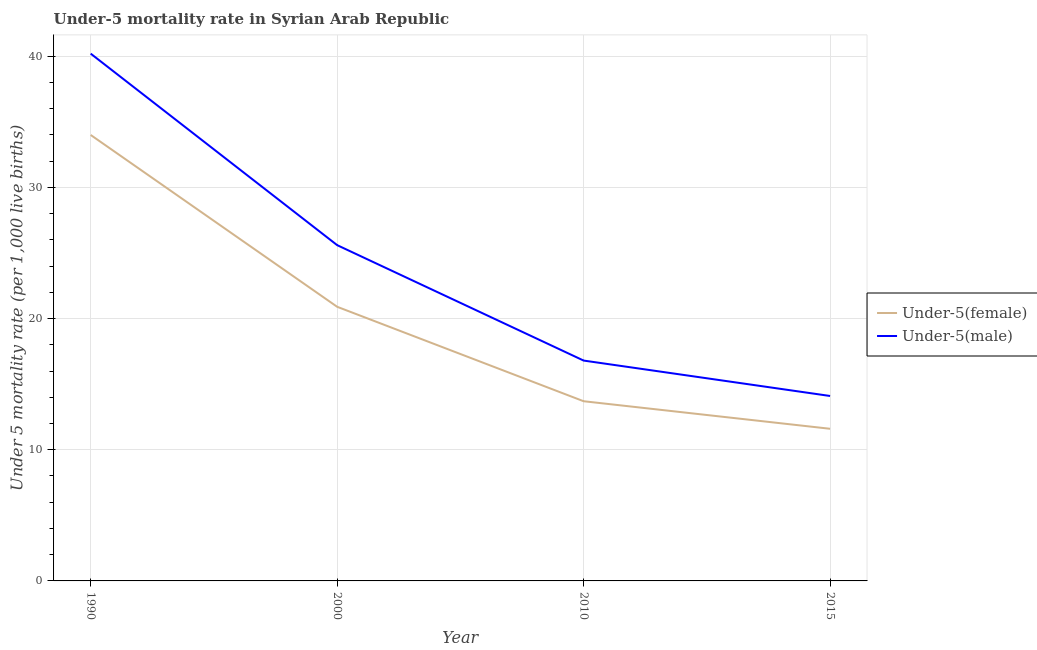Is the number of lines equal to the number of legend labels?
Provide a short and direct response. Yes. What is the under-5 female mortality rate in 2000?
Offer a terse response. 20.9. Across all years, what is the maximum under-5 male mortality rate?
Make the answer very short. 40.2. Across all years, what is the minimum under-5 female mortality rate?
Offer a very short reply. 11.6. In which year was the under-5 male mortality rate minimum?
Offer a very short reply. 2015. What is the total under-5 female mortality rate in the graph?
Your answer should be very brief. 80.2. What is the difference between the under-5 male mortality rate in 2000 and that in 2015?
Provide a succinct answer. 11.5. What is the difference between the under-5 male mortality rate in 2000 and the under-5 female mortality rate in 1990?
Give a very brief answer. -8.4. What is the average under-5 male mortality rate per year?
Provide a succinct answer. 24.18. In the year 2010, what is the difference between the under-5 male mortality rate and under-5 female mortality rate?
Keep it short and to the point. 3.1. In how many years, is the under-5 male mortality rate greater than 10?
Keep it short and to the point. 4. What is the ratio of the under-5 female mortality rate in 2010 to that in 2015?
Give a very brief answer. 1.18. Is the difference between the under-5 female mortality rate in 1990 and 2000 greater than the difference between the under-5 male mortality rate in 1990 and 2000?
Ensure brevity in your answer.  No. What is the difference between the highest and the second highest under-5 male mortality rate?
Give a very brief answer. 14.6. What is the difference between the highest and the lowest under-5 female mortality rate?
Offer a terse response. 22.4. In how many years, is the under-5 male mortality rate greater than the average under-5 male mortality rate taken over all years?
Your response must be concise. 2. Is the under-5 female mortality rate strictly greater than the under-5 male mortality rate over the years?
Your response must be concise. No. Does the graph contain any zero values?
Your answer should be compact. No. Does the graph contain grids?
Give a very brief answer. Yes. Where does the legend appear in the graph?
Offer a terse response. Center right. What is the title of the graph?
Your response must be concise. Under-5 mortality rate in Syrian Arab Republic. Does "Under-5(female)" appear as one of the legend labels in the graph?
Your response must be concise. Yes. What is the label or title of the X-axis?
Give a very brief answer. Year. What is the label or title of the Y-axis?
Offer a very short reply. Under 5 mortality rate (per 1,0 live births). What is the Under 5 mortality rate (per 1,000 live births) of Under-5(male) in 1990?
Make the answer very short. 40.2. What is the Under 5 mortality rate (per 1,000 live births) in Under-5(female) in 2000?
Offer a terse response. 20.9. What is the Under 5 mortality rate (per 1,000 live births) of Under-5(male) in 2000?
Give a very brief answer. 25.6. What is the Under 5 mortality rate (per 1,000 live births) in Under-5(female) in 2010?
Give a very brief answer. 13.7. What is the Under 5 mortality rate (per 1,000 live births) in Under-5(female) in 2015?
Give a very brief answer. 11.6. Across all years, what is the maximum Under 5 mortality rate (per 1,000 live births) of Under-5(female)?
Your response must be concise. 34. Across all years, what is the maximum Under 5 mortality rate (per 1,000 live births) of Under-5(male)?
Keep it short and to the point. 40.2. Across all years, what is the minimum Under 5 mortality rate (per 1,000 live births) of Under-5(male)?
Your answer should be very brief. 14.1. What is the total Under 5 mortality rate (per 1,000 live births) in Under-5(female) in the graph?
Provide a short and direct response. 80.2. What is the total Under 5 mortality rate (per 1,000 live births) in Under-5(male) in the graph?
Give a very brief answer. 96.7. What is the difference between the Under 5 mortality rate (per 1,000 live births) of Under-5(male) in 1990 and that in 2000?
Offer a very short reply. 14.6. What is the difference between the Under 5 mortality rate (per 1,000 live births) in Under-5(female) in 1990 and that in 2010?
Give a very brief answer. 20.3. What is the difference between the Under 5 mortality rate (per 1,000 live births) in Under-5(male) in 1990 and that in 2010?
Make the answer very short. 23.4. What is the difference between the Under 5 mortality rate (per 1,000 live births) in Under-5(female) in 1990 and that in 2015?
Offer a terse response. 22.4. What is the difference between the Under 5 mortality rate (per 1,000 live births) of Under-5(male) in 1990 and that in 2015?
Your answer should be compact. 26.1. What is the difference between the Under 5 mortality rate (per 1,000 live births) in Under-5(female) in 2000 and that in 2010?
Make the answer very short. 7.2. What is the difference between the Under 5 mortality rate (per 1,000 live births) of Under-5(male) in 2000 and that in 2010?
Your response must be concise. 8.8. What is the difference between the Under 5 mortality rate (per 1,000 live births) of Under-5(female) in 2000 and that in 2015?
Your response must be concise. 9.3. What is the difference between the Under 5 mortality rate (per 1,000 live births) of Under-5(male) in 2010 and that in 2015?
Your response must be concise. 2.7. What is the difference between the Under 5 mortality rate (per 1,000 live births) of Under-5(female) in 1990 and the Under 5 mortality rate (per 1,000 live births) of Under-5(male) in 2010?
Give a very brief answer. 17.2. What is the difference between the Under 5 mortality rate (per 1,000 live births) of Under-5(female) in 2000 and the Under 5 mortality rate (per 1,000 live births) of Under-5(male) in 2015?
Provide a short and direct response. 6.8. What is the difference between the Under 5 mortality rate (per 1,000 live births) in Under-5(female) in 2010 and the Under 5 mortality rate (per 1,000 live births) in Under-5(male) in 2015?
Make the answer very short. -0.4. What is the average Under 5 mortality rate (per 1,000 live births) in Under-5(female) per year?
Keep it short and to the point. 20.05. What is the average Under 5 mortality rate (per 1,000 live births) in Under-5(male) per year?
Give a very brief answer. 24.18. In the year 1990, what is the difference between the Under 5 mortality rate (per 1,000 live births) in Under-5(female) and Under 5 mortality rate (per 1,000 live births) in Under-5(male)?
Your response must be concise. -6.2. In the year 2000, what is the difference between the Under 5 mortality rate (per 1,000 live births) in Under-5(female) and Under 5 mortality rate (per 1,000 live births) in Under-5(male)?
Provide a succinct answer. -4.7. In the year 2010, what is the difference between the Under 5 mortality rate (per 1,000 live births) of Under-5(female) and Under 5 mortality rate (per 1,000 live births) of Under-5(male)?
Offer a very short reply. -3.1. In the year 2015, what is the difference between the Under 5 mortality rate (per 1,000 live births) in Under-5(female) and Under 5 mortality rate (per 1,000 live births) in Under-5(male)?
Make the answer very short. -2.5. What is the ratio of the Under 5 mortality rate (per 1,000 live births) of Under-5(female) in 1990 to that in 2000?
Your response must be concise. 1.63. What is the ratio of the Under 5 mortality rate (per 1,000 live births) of Under-5(male) in 1990 to that in 2000?
Offer a very short reply. 1.57. What is the ratio of the Under 5 mortality rate (per 1,000 live births) in Under-5(female) in 1990 to that in 2010?
Offer a terse response. 2.48. What is the ratio of the Under 5 mortality rate (per 1,000 live births) of Under-5(male) in 1990 to that in 2010?
Keep it short and to the point. 2.39. What is the ratio of the Under 5 mortality rate (per 1,000 live births) in Under-5(female) in 1990 to that in 2015?
Give a very brief answer. 2.93. What is the ratio of the Under 5 mortality rate (per 1,000 live births) of Under-5(male) in 1990 to that in 2015?
Make the answer very short. 2.85. What is the ratio of the Under 5 mortality rate (per 1,000 live births) in Under-5(female) in 2000 to that in 2010?
Keep it short and to the point. 1.53. What is the ratio of the Under 5 mortality rate (per 1,000 live births) in Under-5(male) in 2000 to that in 2010?
Keep it short and to the point. 1.52. What is the ratio of the Under 5 mortality rate (per 1,000 live births) in Under-5(female) in 2000 to that in 2015?
Provide a short and direct response. 1.8. What is the ratio of the Under 5 mortality rate (per 1,000 live births) in Under-5(male) in 2000 to that in 2015?
Keep it short and to the point. 1.82. What is the ratio of the Under 5 mortality rate (per 1,000 live births) of Under-5(female) in 2010 to that in 2015?
Your response must be concise. 1.18. What is the ratio of the Under 5 mortality rate (per 1,000 live births) in Under-5(male) in 2010 to that in 2015?
Ensure brevity in your answer.  1.19. What is the difference between the highest and the second highest Under 5 mortality rate (per 1,000 live births) of Under-5(female)?
Your response must be concise. 13.1. What is the difference between the highest and the second highest Under 5 mortality rate (per 1,000 live births) of Under-5(male)?
Offer a very short reply. 14.6. What is the difference between the highest and the lowest Under 5 mortality rate (per 1,000 live births) of Under-5(female)?
Your answer should be compact. 22.4. What is the difference between the highest and the lowest Under 5 mortality rate (per 1,000 live births) of Under-5(male)?
Make the answer very short. 26.1. 